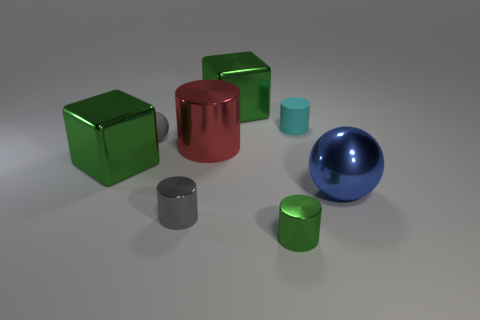How big is the green shiny thing in front of the big ball?
Your response must be concise. Small. How many large green objects have the same shape as the blue shiny thing?
Provide a short and direct response. 0. What shape is the blue object that is the same material as the small green thing?
Your answer should be compact. Sphere. How many gray things are small matte cylinders or rubber objects?
Make the answer very short. 1. There is a tiny gray sphere; are there any matte things left of it?
Keep it short and to the point. No. There is a green thing that is in front of the metal sphere; does it have the same shape as the big metallic object to the right of the small green metallic cylinder?
Your response must be concise. No. There is a large blue thing that is the same shape as the tiny gray matte thing; what material is it?
Ensure brevity in your answer.  Metal. How many balls are either rubber objects or big blue metallic things?
Ensure brevity in your answer.  2. What number of tiny gray cylinders have the same material as the large red object?
Your response must be concise. 1. Do the green block behind the small cyan rubber object and the gray cylinder in front of the small cyan thing have the same material?
Keep it short and to the point. Yes. 